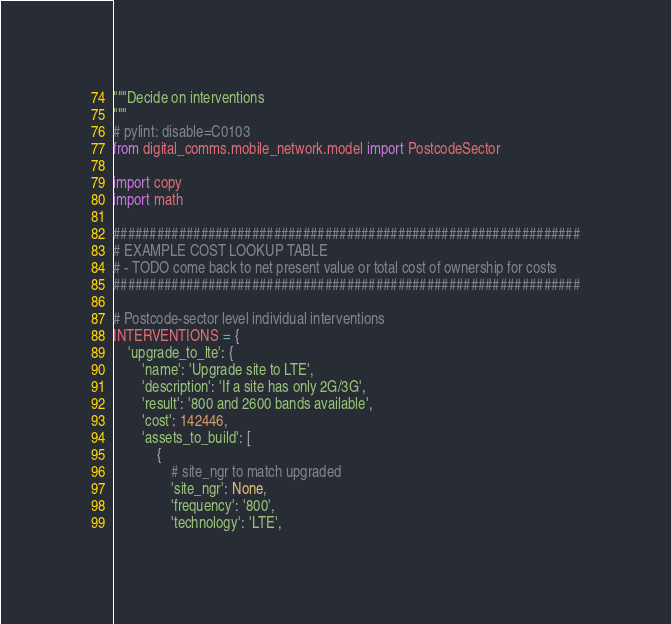<code> <loc_0><loc_0><loc_500><loc_500><_Python_>"""Decide on interventions
"""
# pylint: disable=C0103
from digital_comms.mobile_network.model import PostcodeSector

import copy
import math

################################################################
# EXAMPLE COST LOOKUP TABLE
# - TODO come back to net present value or total cost of ownership for costs
################################################################

# Postcode-sector level individual interventions
INTERVENTIONS = {
    'upgrade_to_lte': {
        'name': 'Upgrade site to LTE',
        'description': 'If a site has only 2G/3G',
        'result': '800 and 2600 bands available',
        'cost': 142446,
        'assets_to_build': [
            {
                # site_ngr to match upgraded
                'site_ngr': None,
                'frequency': '800',
                'technology': 'LTE',</code> 